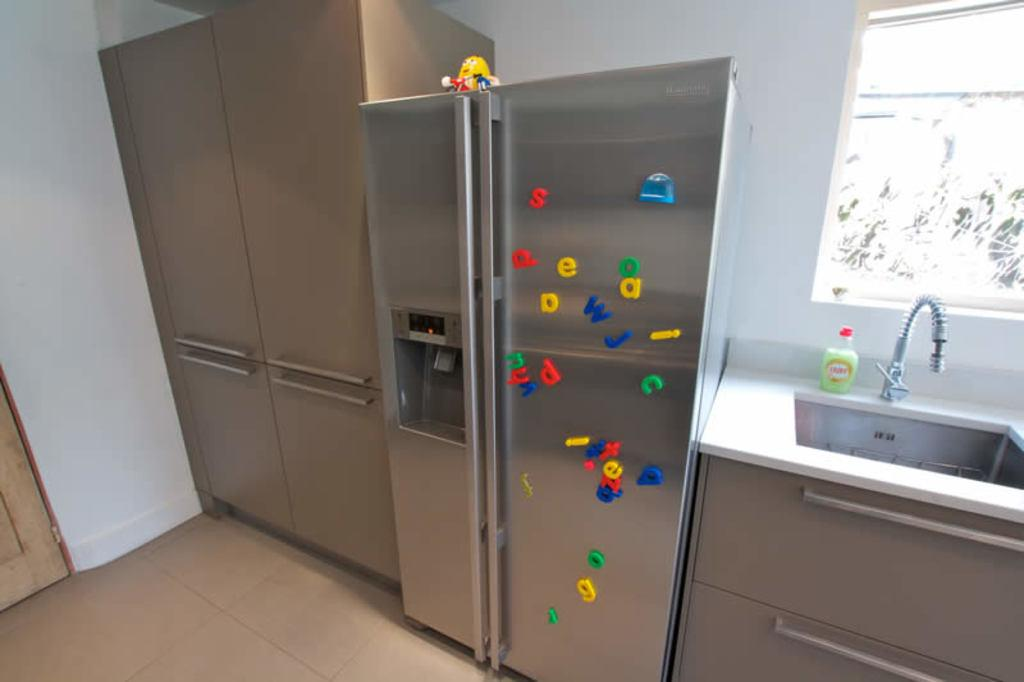<image>
Provide a brief description of the given image. Alphabet magnets with lowercase letters such as g, w, and j are scattered across a silver colored refrigerator in a kitchen. 